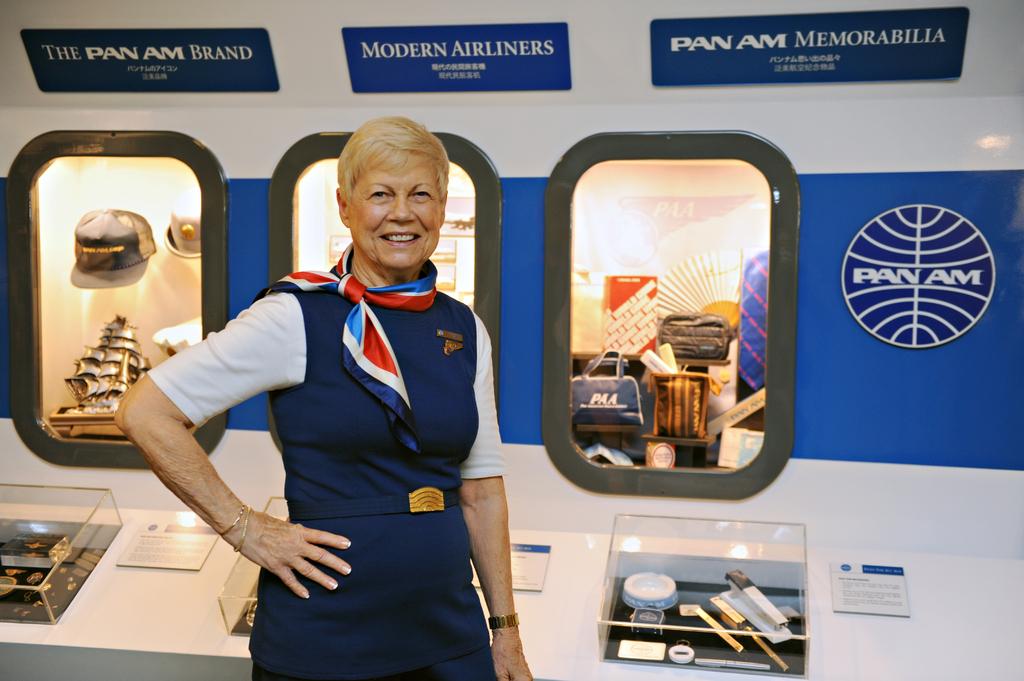What is the brand name of the airline?
Provide a short and direct response. Pan am. What word is after pan am on far right?
Provide a short and direct response. Memorabilia. 